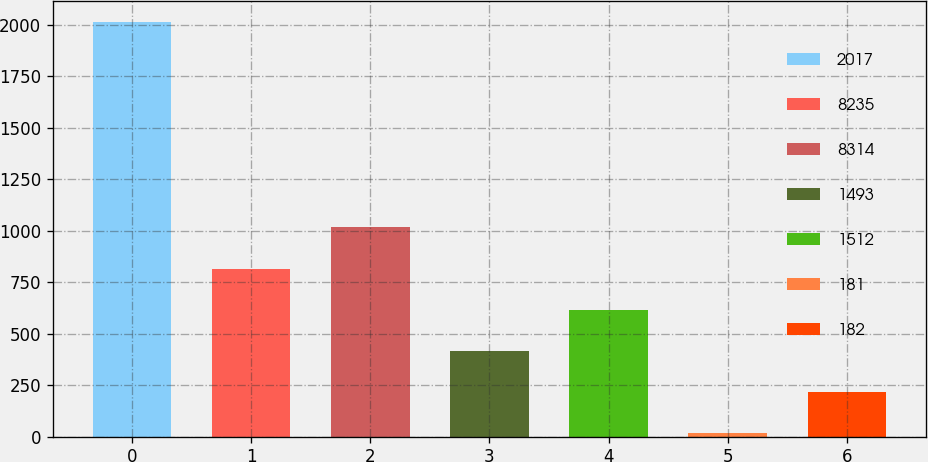Convert chart. <chart><loc_0><loc_0><loc_500><loc_500><bar_chart><fcel>2017<fcel>8235<fcel>8314<fcel>1493<fcel>1512<fcel>181<fcel>182<nl><fcel>2015<fcel>816.08<fcel>1015.9<fcel>416.44<fcel>616.26<fcel>16.8<fcel>216.62<nl></chart> 